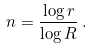Convert formula to latex. <formula><loc_0><loc_0><loc_500><loc_500>n = \frac { \log r } { \log R } \, .</formula> 